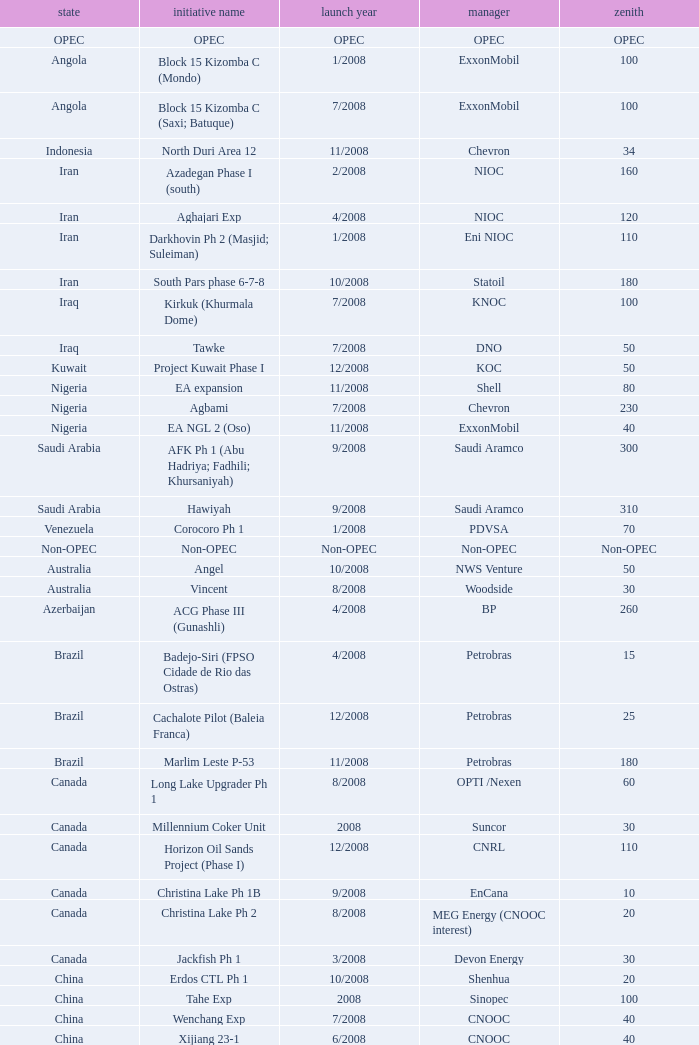What is the operator with a maximum of 55? PEMEX. 